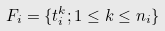<formula> <loc_0><loc_0><loc_500><loc_500>F _ { i } = \{ t ^ { k } _ { i } ; 1 \leq k \leq n _ { i } \}</formula> 